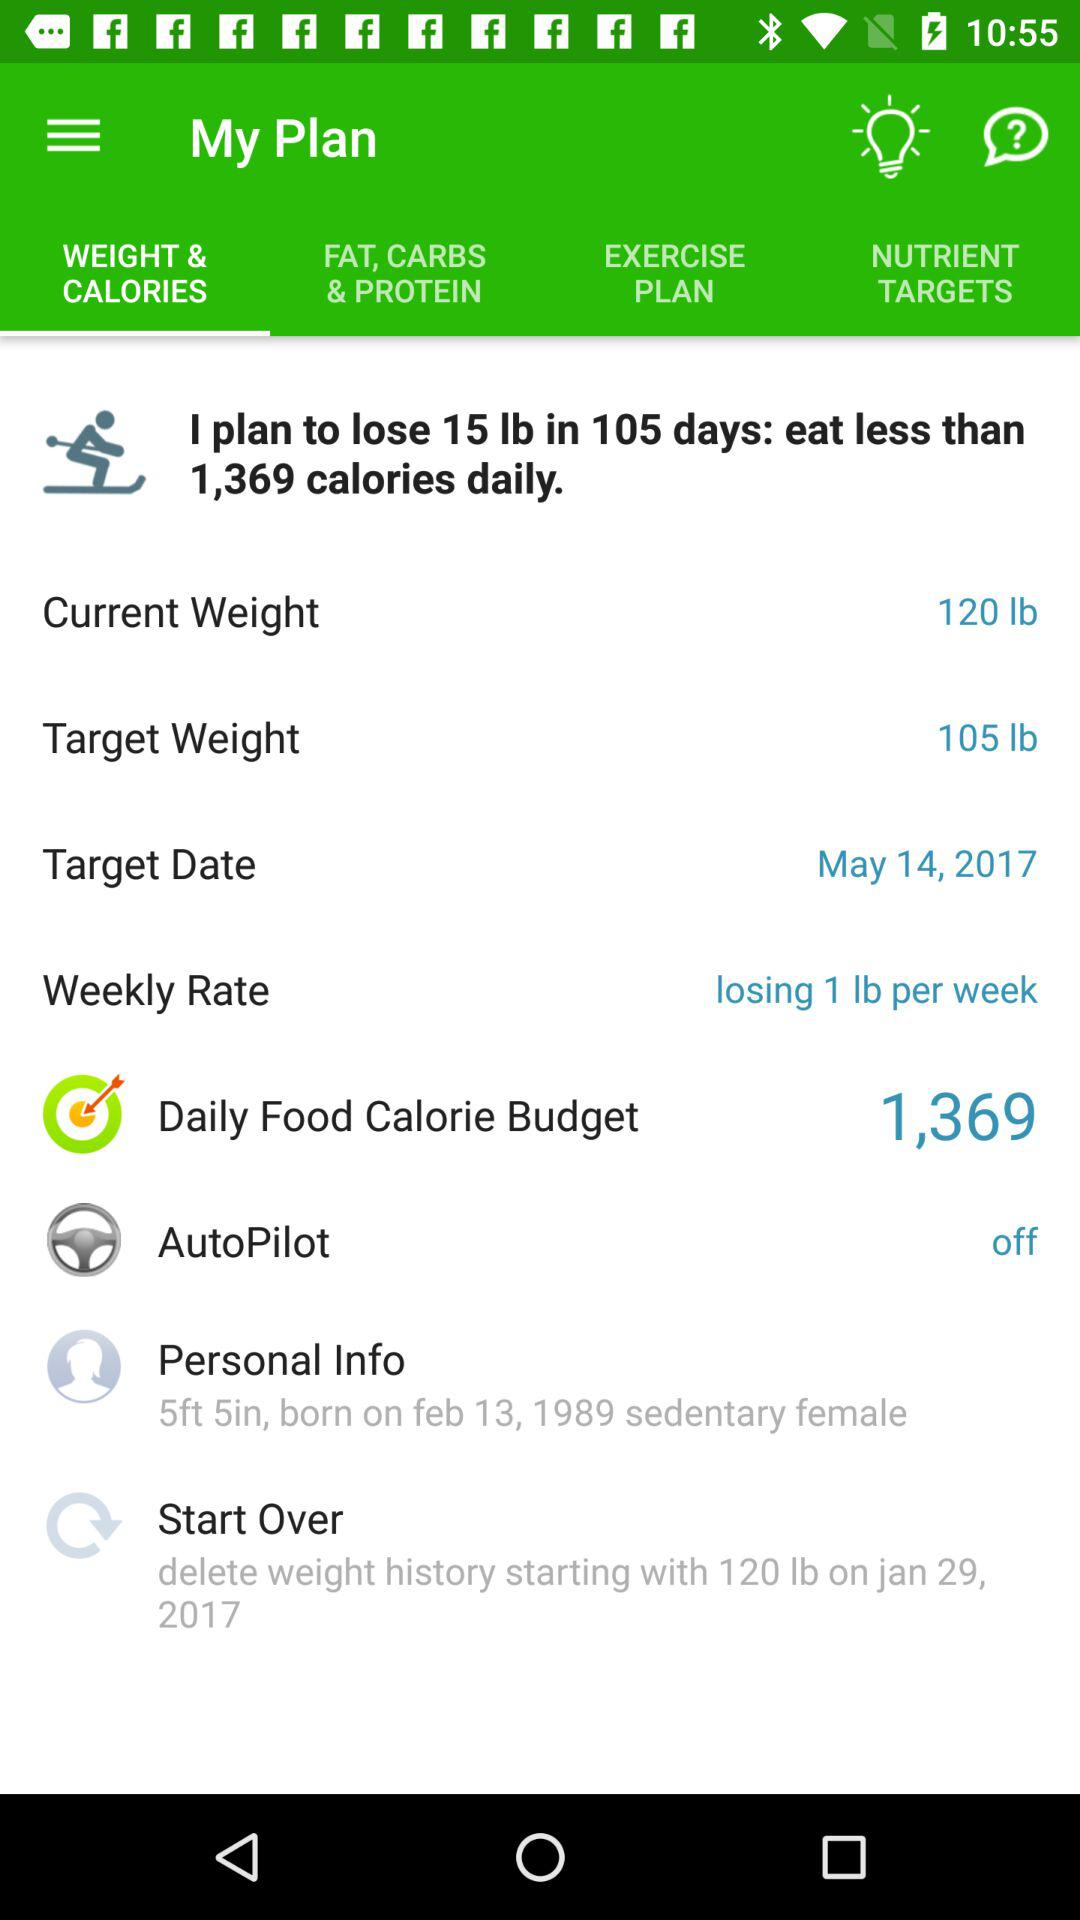How many days does the user plan to lose 15 lb? The user plans to lose 15 lb in 105 days. 